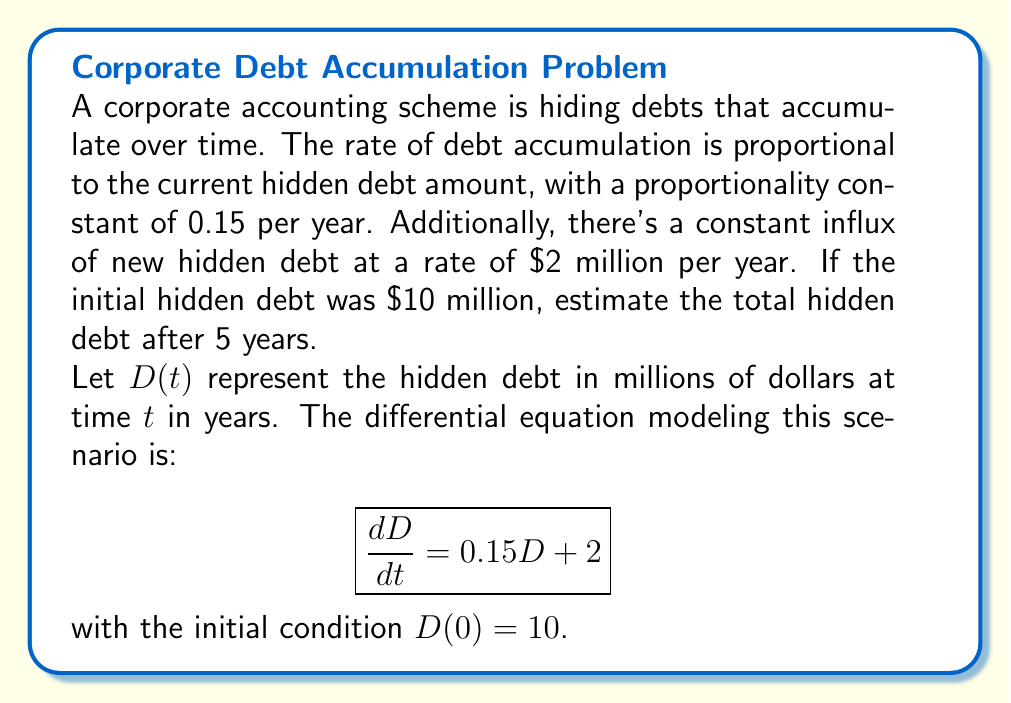Could you help me with this problem? To solve this first-order linear differential equation:

1) The general solution for this type of equation is:
   $$D(t) = ce^{0.15t} - \frac{2}{0.15}$$
   where $c$ is a constant to be determined.

2) Using the initial condition $D(0) = 10$:
   $$10 = c - \frac{2}{0.15}$$
   $$c = 10 + \frac{2}{0.15} = 10 + 13.33 = 23.33$$

3) Therefore, the particular solution is:
   $$D(t) = 23.33e^{0.15t} - 13.33$$

4) To find the hidden debt after 5 years, we evaluate $D(5)$:
   $$D(5) = 23.33e^{0.15(5)} - 13.33$$
   $$= 23.33e^{0.75} - 13.33$$
   $$= 23.33(2.117) - 13.33$$
   $$= 49.39 - 13.33$$
   $$= 36.06$$

5) Therefore, the estimated total hidden debt after 5 years is $36.06 million.
Answer: $36.06 million 